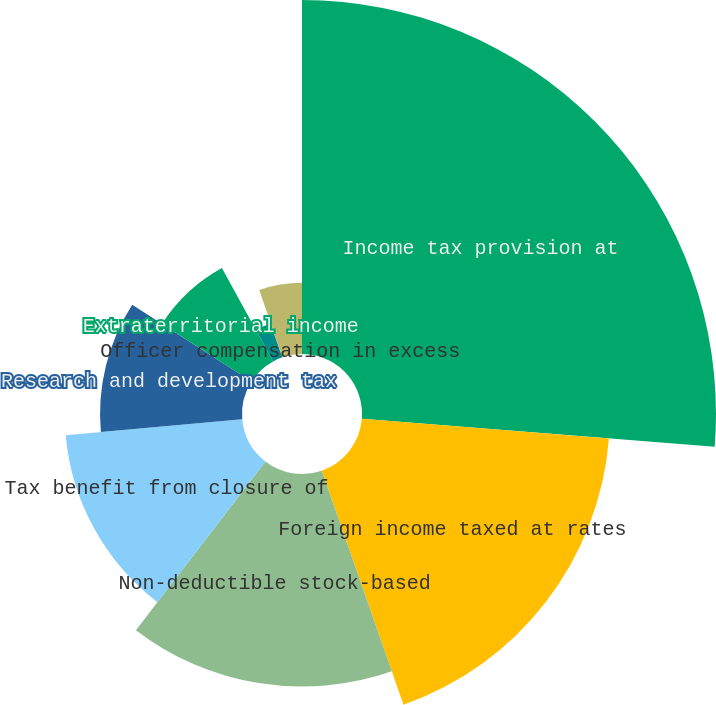<chart> <loc_0><loc_0><loc_500><loc_500><pie_chart><fcel>Income tax provision at<fcel>Foreign income taxed at rates<fcel>Non-deductible stock-based<fcel>Tax benefit from closure of<fcel>Research and development tax<fcel>Extraterritorial income<fcel>State income taxes net of the<fcel>Officer compensation in excess<fcel>Other<nl><fcel>26.26%<fcel>18.39%<fcel>15.77%<fcel>13.15%<fcel>10.53%<fcel>7.91%<fcel>2.66%<fcel>0.04%<fcel>5.28%<nl></chart> 